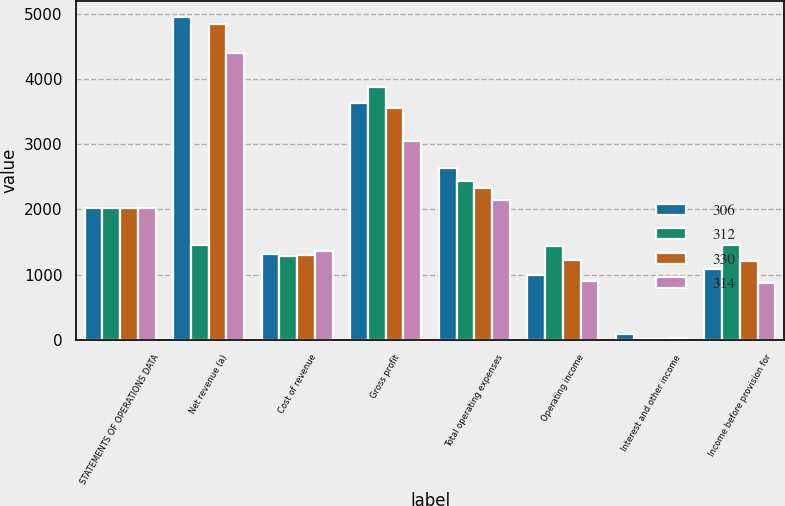<chart> <loc_0><loc_0><loc_500><loc_500><stacked_bar_chart><ecel><fcel>STATEMENTS OF OPERATIONS DATA<fcel>Net revenue (a)<fcel>Cost of revenue<fcel>Gross profit<fcel>Total operating expenses<fcel>Operating income<fcel>Interest and other income<fcel>Income before provision for<nl><fcel>306<fcel>2019<fcel>4950<fcel>1322<fcel>3628<fcel>2632<fcel>996<fcel>83<fcel>1079<nl><fcel>312<fcel>2018<fcel>1449<fcel>1277<fcel>3873<fcel>2439<fcel>1434<fcel>15<fcel>1449<nl><fcel>330<fcel>2017<fcel>4845<fcel>1298<fcel>3547<fcel>2323<fcel>1224<fcel>14<fcel>1210<nl><fcel>314<fcel>2016<fcel>4396<fcel>1354<fcel>3042<fcel>2144<fcel>898<fcel>21<fcel>877<nl></chart> 